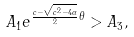Convert formula to latex. <formula><loc_0><loc_0><loc_500><loc_500>A _ { 1 } e ^ { \frac { c - \sqrt { c ^ { 2 } - 4 \alpha } } { 2 } \theta } > A _ { 3 } ,</formula> 